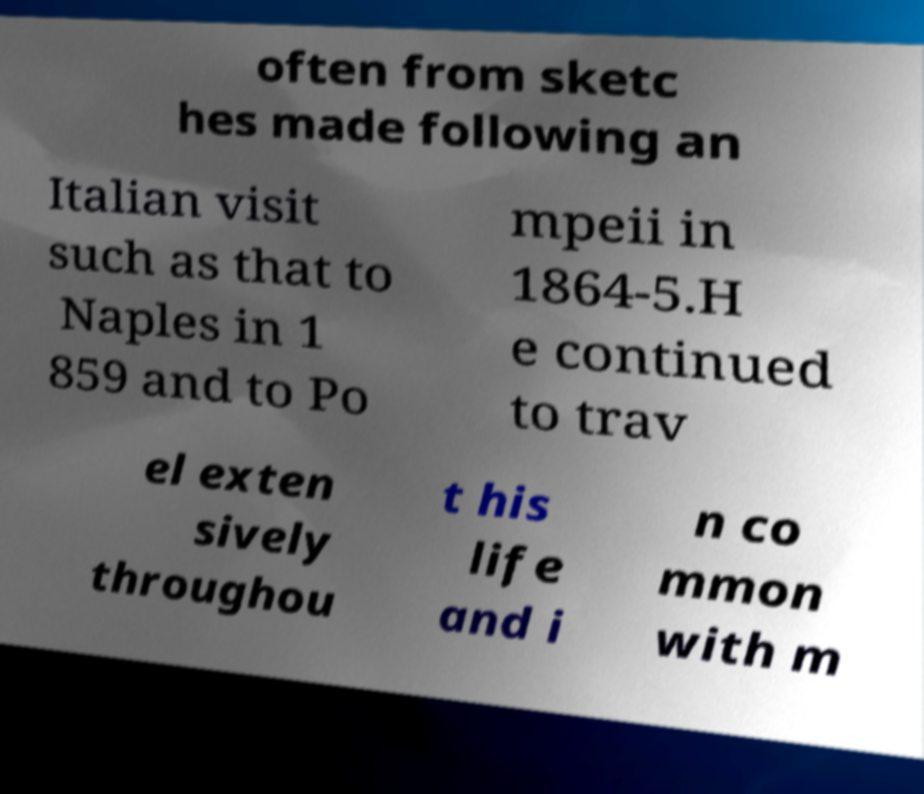What messages or text are displayed in this image? I need them in a readable, typed format. often from sketc hes made following an Italian visit such as that to Naples in 1 859 and to Po mpeii in 1864-5.H e continued to trav el exten sively throughou t his life and i n co mmon with m 